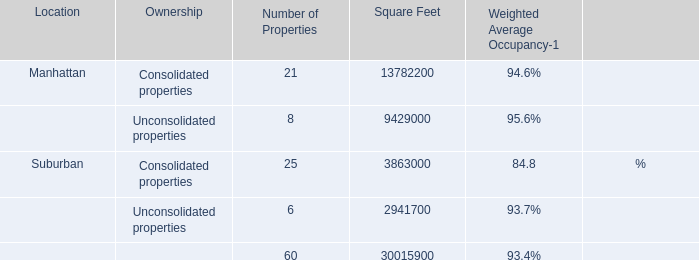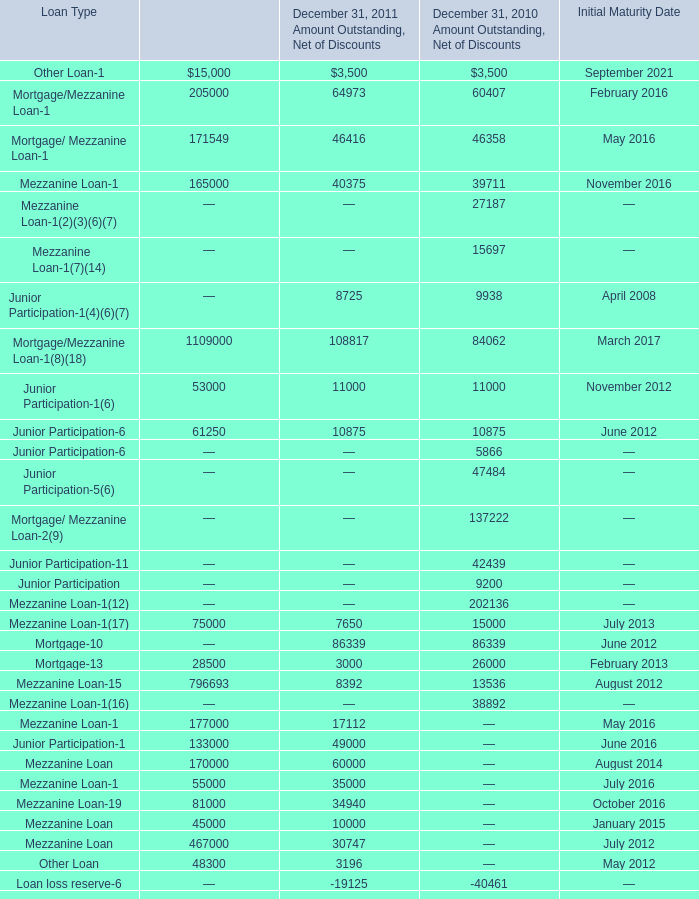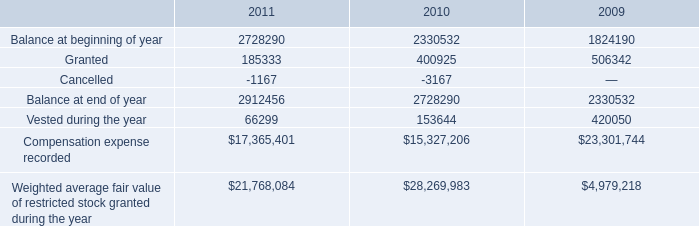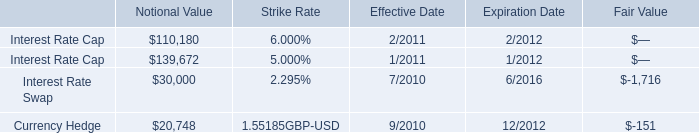what percentage of the beginning balance of 2010 was vested during the year? 
Computations: (153644 / 2330532)
Answer: 0.06593. 